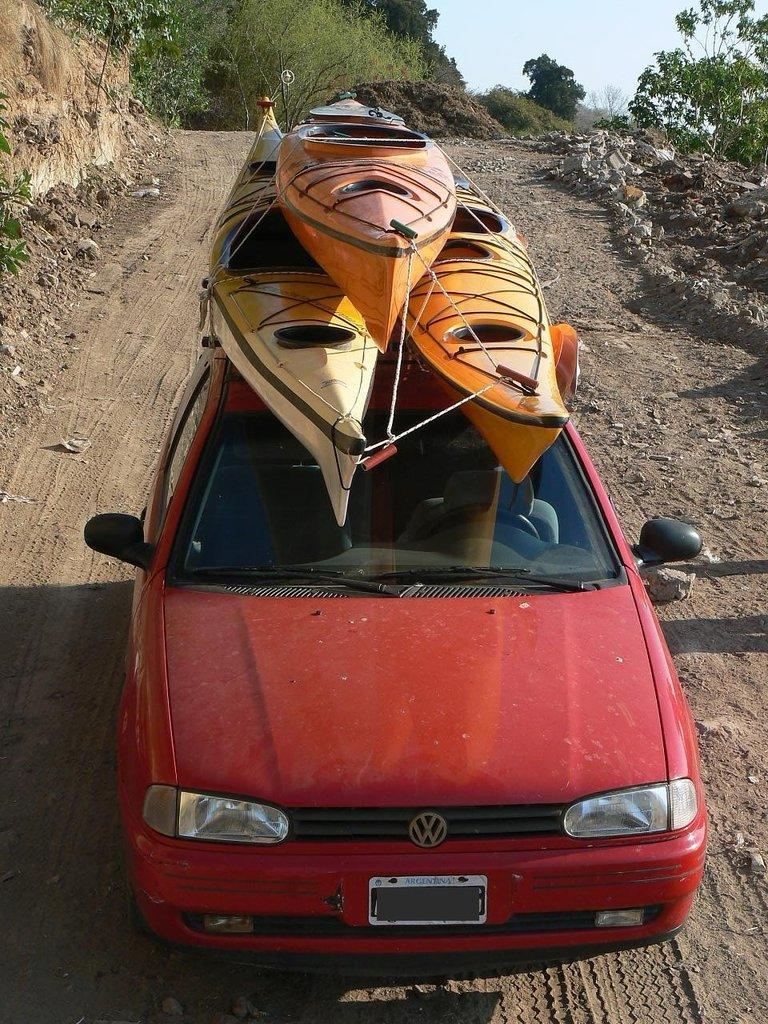What is located on the path in the image? There is a vehicle on the path in the image. What can be seen on the vehicle? There are objects on the vehicle. What type of natural environment is visible in the background of the image? There are trees in the background of the image. What is visible beyond the trees in the image? The sky is visible in the background of the image. What nation is the mom playing with in the image? There is no mom or nation present in the image; it only features a vehicle on a path with objects on it, trees in the background, and the sky visible. 